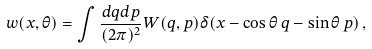Convert formula to latex. <formula><loc_0><loc_0><loc_500><loc_500>w ( x , \theta ) = \int \frac { d q d p } { ( 2 \pi ) ^ { 2 } } W ( q , p ) \delta ( x - \cos \theta \, q - \sin \theta \, p ) \, ,</formula> 